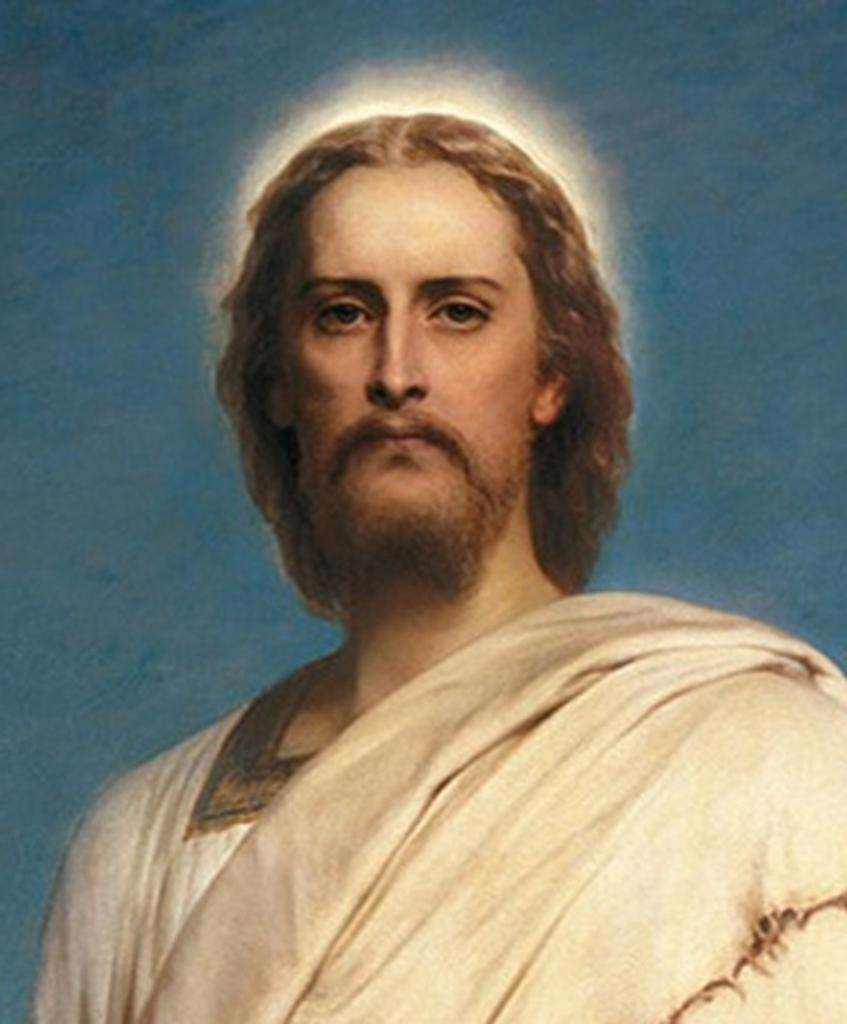Who is present in the image? There is a man in the image. What is the man wearing? The man is wearing a white dress. What colors can be seen in the background of the image? The background of the image includes blue and white colors. What type of star can be seen in the image? There is no star present in the image; it features a man wearing a white dress with a blue and white background. 